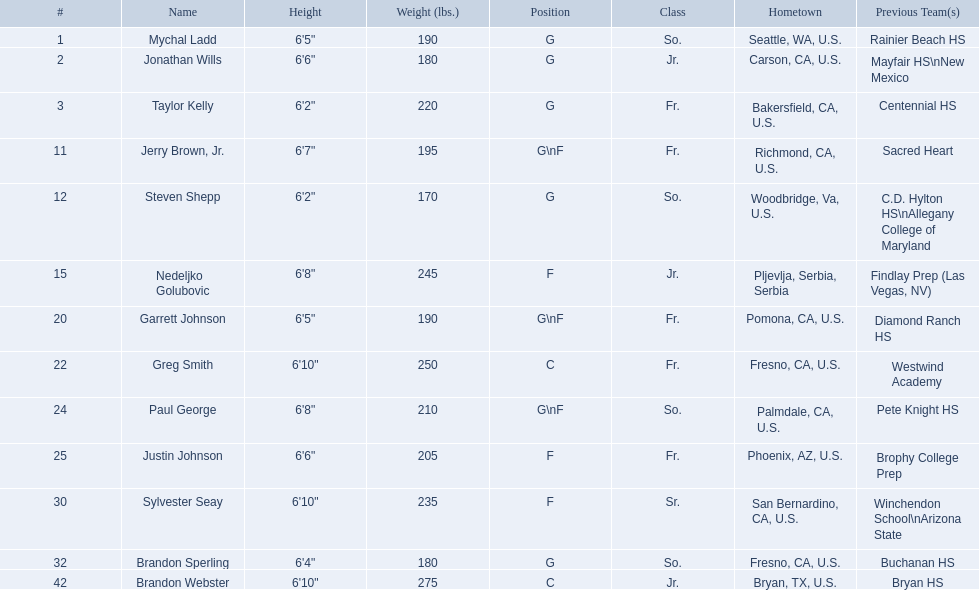What are the itemized classifications of the players? So., Jr., Fr., Fr., So., Jr., Fr., Fr., So., Fr., Sr., So., Jr. Which of these is not from the us? Jr. To which epithet does that listing associate with? Nedeljko Golubovic. 